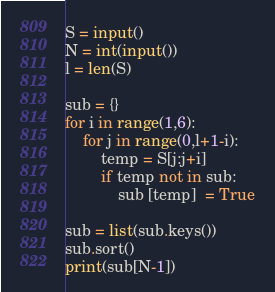Convert code to text. <code><loc_0><loc_0><loc_500><loc_500><_Python_>

S = input()
N = int(input())
l = len(S)

sub = {}
for i in range(1,6):
    for j in range(0,l+1-i):
        temp = S[j:j+i]
        if temp not in sub:
            sub [temp]  = True

sub = list(sub.keys())
sub.sort()
print(sub[N-1])



</code> 